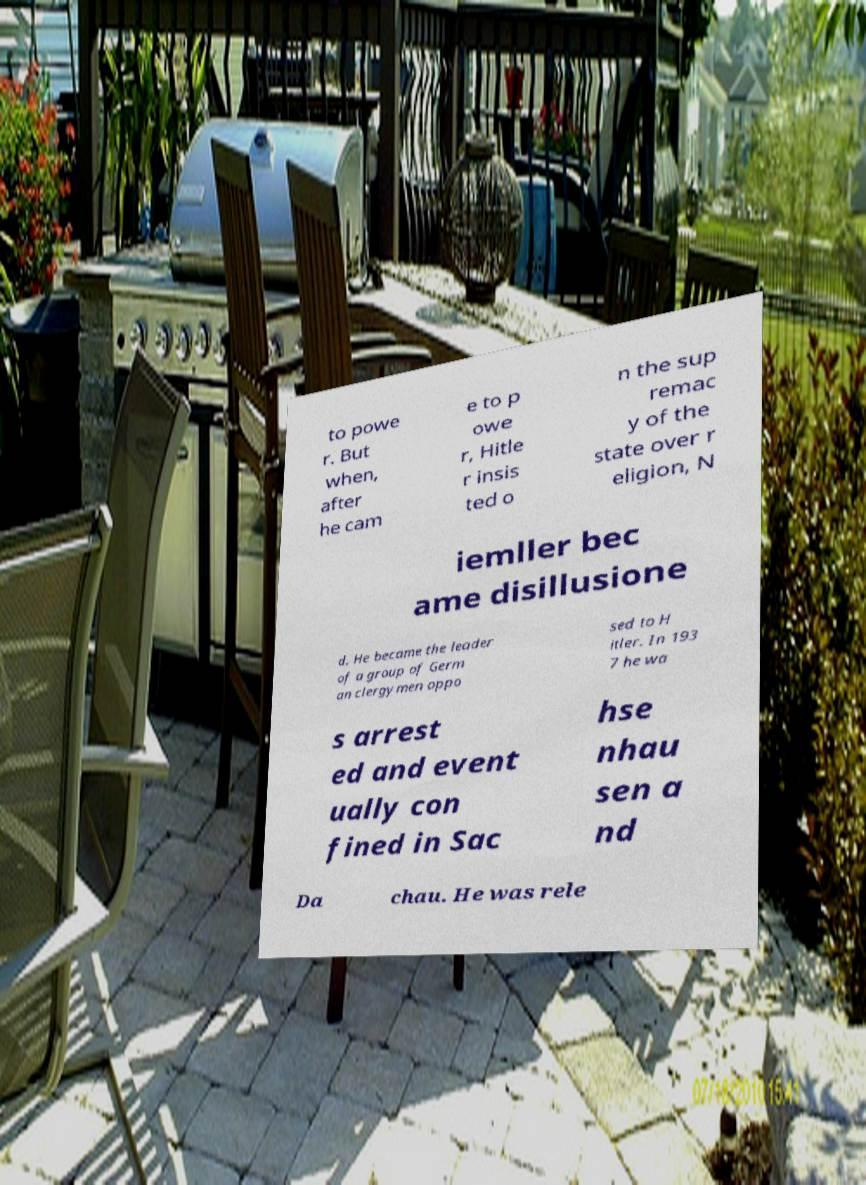Can you read and provide the text displayed in the image?This photo seems to have some interesting text. Can you extract and type it out for me? to powe r. But when, after he cam e to p owe r, Hitle r insis ted o n the sup remac y of the state over r eligion, N iemller bec ame disillusione d. He became the leader of a group of Germ an clergymen oppo sed to H itler. In 193 7 he wa s arrest ed and event ually con fined in Sac hse nhau sen a nd Da chau. He was rele 